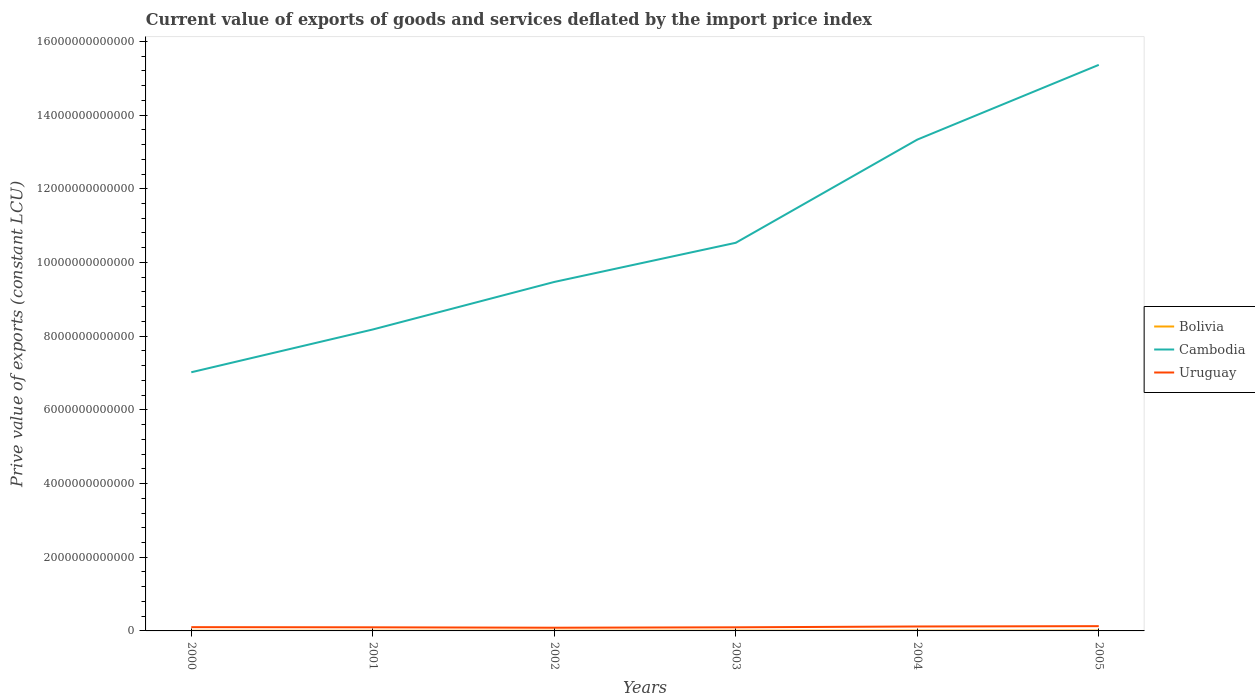How many different coloured lines are there?
Give a very brief answer. 3. Is the number of lines equal to the number of legend labels?
Keep it short and to the point. Yes. Across all years, what is the maximum prive value of exports in Uruguay?
Your answer should be compact. 8.71e+1. In which year was the prive value of exports in Bolivia maximum?
Give a very brief answer. 2000. What is the total prive value of exports in Cambodia in the graph?
Keep it short and to the point. -2.03e+12. What is the difference between the highest and the second highest prive value of exports in Bolivia?
Give a very brief answer. 5.01e+09. What is the difference between two consecutive major ticks on the Y-axis?
Offer a very short reply. 2.00e+12. What is the title of the graph?
Keep it short and to the point. Current value of exports of goods and services deflated by the import price index. Does "Libya" appear as one of the legend labels in the graph?
Give a very brief answer. No. What is the label or title of the Y-axis?
Your response must be concise. Prive value of exports (constant LCU). What is the Prive value of exports (constant LCU) in Bolivia in 2000?
Offer a terse response. 4.27e+09. What is the Prive value of exports (constant LCU) in Cambodia in 2000?
Make the answer very short. 7.02e+12. What is the Prive value of exports (constant LCU) of Uruguay in 2000?
Provide a short and direct response. 1.02e+11. What is the Prive value of exports (constant LCU) in Bolivia in 2001?
Your response must be concise. 4.80e+09. What is the Prive value of exports (constant LCU) of Cambodia in 2001?
Your response must be concise. 8.18e+12. What is the Prive value of exports (constant LCU) in Uruguay in 2001?
Ensure brevity in your answer.  9.80e+1. What is the Prive value of exports (constant LCU) in Bolivia in 2002?
Your answer should be compact. 5.35e+09. What is the Prive value of exports (constant LCU) in Cambodia in 2002?
Keep it short and to the point. 9.47e+12. What is the Prive value of exports (constant LCU) in Uruguay in 2002?
Your response must be concise. 8.71e+1. What is the Prive value of exports (constant LCU) in Bolivia in 2003?
Give a very brief answer. 6.72e+09. What is the Prive value of exports (constant LCU) of Cambodia in 2003?
Ensure brevity in your answer.  1.05e+13. What is the Prive value of exports (constant LCU) in Uruguay in 2003?
Keep it short and to the point. 9.78e+1. What is the Prive value of exports (constant LCU) of Bolivia in 2004?
Give a very brief answer. 8.63e+09. What is the Prive value of exports (constant LCU) of Cambodia in 2004?
Provide a short and direct response. 1.33e+13. What is the Prive value of exports (constant LCU) in Uruguay in 2004?
Your response must be concise. 1.20e+11. What is the Prive value of exports (constant LCU) in Bolivia in 2005?
Your answer should be compact. 9.28e+09. What is the Prive value of exports (constant LCU) in Cambodia in 2005?
Your answer should be very brief. 1.54e+13. What is the Prive value of exports (constant LCU) in Uruguay in 2005?
Ensure brevity in your answer.  1.29e+11. Across all years, what is the maximum Prive value of exports (constant LCU) of Bolivia?
Give a very brief answer. 9.28e+09. Across all years, what is the maximum Prive value of exports (constant LCU) of Cambodia?
Provide a succinct answer. 1.54e+13. Across all years, what is the maximum Prive value of exports (constant LCU) in Uruguay?
Your answer should be very brief. 1.29e+11. Across all years, what is the minimum Prive value of exports (constant LCU) in Bolivia?
Make the answer very short. 4.27e+09. Across all years, what is the minimum Prive value of exports (constant LCU) in Cambodia?
Your answer should be compact. 7.02e+12. Across all years, what is the minimum Prive value of exports (constant LCU) of Uruguay?
Your answer should be compact. 8.71e+1. What is the total Prive value of exports (constant LCU) of Bolivia in the graph?
Make the answer very short. 3.91e+1. What is the total Prive value of exports (constant LCU) in Cambodia in the graph?
Your answer should be very brief. 6.39e+13. What is the total Prive value of exports (constant LCU) in Uruguay in the graph?
Give a very brief answer. 6.34e+11. What is the difference between the Prive value of exports (constant LCU) of Bolivia in 2000 and that in 2001?
Give a very brief answer. -5.24e+08. What is the difference between the Prive value of exports (constant LCU) in Cambodia in 2000 and that in 2001?
Your answer should be very brief. -1.16e+12. What is the difference between the Prive value of exports (constant LCU) of Uruguay in 2000 and that in 2001?
Offer a terse response. 4.12e+09. What is the difference between the Prive value of exports (constant LCU) in Bolivia in 2000 and that in 2002?
Keep it short and to the point. -1.08e+09. What is the difference between the Prive value of exports (constant LCU) in Cambodia in 2000 and that in 2002?
Your answer should be very brief. -2.45e+12. What is the difference between the Prive value of exports (constant LCU) of Uruguay in 2000 and that in 2002?
Ensure brevity in your answer.  1.50e+1. What is the difference between the Prive value of exports (constant LCU) of Bolivia in 2000 and that in 2003?
Offer a very short reply. -2.45e+09. What is the difference between the Prive value of exports (constant LCU) in Cambodia in 2000 and that in 2003?
Your response must be concise. -3.51e+12. What is the difference between the Prive value of exports (constant LCU) of Uruguay in 2000 and that in 2003?
Offer a very short reply. 4.28e+09. What is the difference between the Prive value of exports (constant LCU) in Bolivia in 2000 and that in 2004?
Keep it short and to the point. -4.36e+09. What is the difference between the Prive value of exports (constant LCU) of Cambodia in 2000 and that in 2004?
Offer a very short reply. -6.31e+12. What is the difference between the Prive value of exports (constant LCU) in Uruguay in 2000 and that in 2004?
Keep it short and to the point. -1.82e+1. What is the difference between the Prive value of exports (constant LCU) of Bolivia in 2000 and that in 2005?
Ensure brevity in your answer.  -5.01e+09. What is the difference between the Prive value of exports (constant LCU) of Cambodia in 2000 and that in 2005?
Your answer should be very brief. -8.34e+12. What is the difference between the Prive value of exports (constant LCU) in Uruguay in 2000 and that in 2005?
Offer a very short reply. -2.71e+1. What is the difference between the Prive value of exports (constant LCU) in Bolivia in 2001 and that in 2002?
Keep it short and to the point. -5.58e+08. What is the difference between the Prive value of exports (constant LCU) in Cambodia in 2001 and that in 2002?
Give a very brief answer. -1.29e+12. What is the difference between the Prive value of exports (constant LCU) of Uruguay in 2001 and that in 2002?
Offer a very short reply. 1.09e+1. What is the difference between the Prive value of exports (constant LCU) of Bolivia in 2001 and that in 2003?
Give a very brief answer. -1.92e+09. What is the difference between the Prive value of exports (constant LCU) of Cambodia in 2001 and that in 2003?
Offer a very short reply. -2.35e+12. What is the difference between the Prive value of exports (constant LCU) of Uruguay in 2001 and that in 2003?
Give a very brief answer. 1.57e+08. What is the difference between the Prive value of exports (constant LCU) in Bolivia in 2001 and that in 2004?
Give a very brief answer. -3.84e+09. What is the difference between the Prive value of exports (constant LCU) in Cambodia in 2001 and that in 2004?
Make the answer very short. -5.15e+12. What is the difference between the Prive value of exports (constant LCU) of Uruguay in 2001 and that in 2004?
Offer a very short reply. -2.23e+1. What is the difference between the Prive value of exports (constant LCU) of Bolivia in 2001 and that in 2005?
Provide a short and direct response. -4.49e+09. What is the difference between the Prive value of exports (constant LCU) in Cambodia in 2001 and that in 2005?
Your response must be concise. -7.18e+12. What is the difference between the Prive value of exports (constant LCU) of Uruguay in 2001 and that in 2005?
Your answer should be compact. -3.13e+1. What is the difference between the Prive value of exports (constant LCU) of Bolivia in 2002 and that in 2003?
Give a very brief answer. -1.37e+09. What is the difference between the Prive value of exports (constant LCU) in Cambodia in 2002 and that in 2003?
Offer a very short reply. -1.06e+12. What is the difference between the Prive value of exports (constant LCU) of Uruguay in 2002 and that in 2003?
Keep it short and to the point. -1.07e+1. What is the difference between the Prive value of exports (constant LCU) in Bolivia in 2002 and that in 2004?
Ensure brevity in your answer.  -3.28e+09. What is the difference between the Prive value of exports (constant LCU) in Cambodia in 2002 and that in 2004?
Make the answer very short. -3.86e+12. What is the difference between the Prive value of exports (constant LCU) in Uruguay in 2002 and that in 2004?
Keep it short and to the point. -3.31e+1. What is the difference between the Prive value of exports (constant LCU) of Bolivia in 2002 and that in 2005?
Offer a terse response. -3.93e+09. What is the difference between the Prive value of exports (constant LCU) in Cambodia in 2002 and that in 2005?
Your response must be concise. -5.89e+12. What is the difference between the Prive value of exports (constant LCU) of Uruguay in 2002 and that in 2005?
Offer a terse response. -4.21e+1. What is the difference between the Prive value of exports (constant LCU) of Bolivia in 2003 and that in 2004?
Make the answer very short. -1.91e+09. What is the difference between the Prive value of exports (constant LCU) of Cambodia in 2003 and that in 2004?
Your answer should be compact. -2.80e+12. What is the difference between the Prive value of exports (constant LCU) in Uruguay in 2003 and that in 2004?
Provide a short and direct response. -2.24e+1. What is the difference between the Prive value of exports (constant LCU) of Bolivia in 2003 and that in 2005?
Provide a short and direct response. -2.56e+09. What is the difference between the Prive value of exports (constant LCU) in Cambodia in 2003 and that in 2005?
Offer a terse response. -4.83e+12. What is the difference between the Prive value of exports (constant LCU) of Uruguay in 2003 and that in 2005?
Give a very brief answer. -3.14e+1. What is the difference between the Prive value of exports (constant LCU) of Bolivia in 2004 and that in 2005?
Keep it short and to the point. -6.47e+08. What is the difference between the Prive value of exports (constant LCU) in Cambodia in 2004 and that in 2005?
Your answer should be compact. -2.03e+12. What is the difference between the Prive value of exports (constant LCU) in Uruguay in 2004 and that in 2005?
Ensure brevity in your answer.  -8.98e+09. What is the difference between the Prive value of exports (constant LCU) in Bolivia in 2000 and the Prive value of exports (constant LCU) in Cambodia in 2001?
Ensure brevity in your answer.  -8.18e+12. What is the difference between the Prive value of exports (constant LCU) in Bolivia in 2000 and the Prive value of exports (constant LCU) in Uruguay in 2001?
Give a very brief answer. -9.37e+1. What is the difference between the Prive value of exports (constant LCU) in Cambodia in 2000 and the Prive value of exports (constant LCU) in Uruguay in 2001?
Make the answer very short. 6.92e+12. What is the difference between the Prive value of exports (constant LCU) of Bolivia in 2000 and the Prive value of exports (constant LCU) of Cambodia in 2002?
Provide a short and direct response. -9.47e+12. What is the difference between the Prive value of exports (constant LCU) in Bolivia in 2000 and the Prive value of exports (constant LCU) in Uruguay in 2002?
Your answer should be compact. -8.28e+1. What is the difference between the Prive value of exports (constant LCU) of Cambodia in 2000 and the Prive value of exports (constant LCU) of Uruguay in 2002?
Your answer should be very brief. 6.93e+12. What is the difference between the Prive value of exports (constant LCU) in Bolivia in 2000 and the Prive value of exports (constant LCU) in Cambodia in 2003?
Keep it short and to the point. -1.05e+13. What is the difference between the Prive value of exports (constant LCU) of Bolivia in 2000 and the Prive value of exports (constant LCU) of Uruguay in 2003?
Ensure brevity in your answer.  -9.35e+1. What is the difference between the Prive value of exports (constant LCU) in Cambodia in 2000 and the Prive value of exports (constant LCU) in Uruguay in 2003?
Ensure brevity in your answer.  6.92e+12. What is the difference between the Prive value of exports (constant LCU) in Bolivia in 2000 and the Prive value of exports (constant LCU) in Cambodia in 2004?
Offer a very short reply. -1.33e+13. What is the difference between the Prive value of exports (constant LCU) of Bolivia in 2000 and the Prive value of exports (constant LCU) of Uruguay in 2004?
Your response must be concise. -1.16e+11. What is the difference between the Prive value of exports (constant LCU) in Cambodia in 2000 and the Prive value of exports (constant LCU) in Uruguay in 2004?
Your answer should be compact. 6.90e+12. What is the difference between the Prive value of exports (constant LCU) in Bolivia in 2000 and the Prive value of exports (constant LCU) in Cambodia in 2005?
Offer a terse response. -1.54e+13. What is the difference between the Prive value of exports (constant LCU) of Bolivia in 2000 and the Prive value of exports (constant LCU) of Uruguay in 2005?
Offer a terse response. -1.25e+11. What is the difference between the Prive value of exports (constant LCU) in Cambodia in 2000 and the Prive value of exports (constant LCU) in Uruguay in 2005?
Provide a short and direct response. 6.89e+12. What is the difference between the Prive value of exports (constant LCU) of Bolivia in 2001 and the Prive value of exports (constant LCU) of Cambodia in 2002?
Ensure brevity in your answer.  -9.47e+12. What is the difference between the Prive value of exports (constant LCU) in Bolivia in 2001 and the Prive value of exports (constant LCU) in Uruguay in 2002?
Offer a very short reply. -8.23e+1. What is the difference between the Prive value of exports (constant LCU) in Cambodia in 2001 and the Prive value of exports (constant LCU) in Uruguay in 2002?
Provide a short and direct response. 8.09e+12. What is the difference between the Prive value of exports (constant LCU) in Bolivia in 2001 and the Prive value of exports (constant LCU) in Cambodia in 2003?
Your answer should be very brief. -1.05e+13. What is the difference between the Prive value of exports (constant LCU) of Bolivia in 2001 and the Prive value of exports (constant LCU) of Uruguay in 2003?
Your response must be concise. -9.30e+1. What is the difference between the Prive value of exports (constant LCU) of Cambodia in 2001 and the Prive value of exports (constant LCU) of Uruguay in 2003?
Your answer should be compact. 8.08e+12. What is the difference between the Prive value of exports (constant LCU) of Bolivia in 2001 and the Prive value of exports (constant LCU) of Cambodia in 2004?
Give a very brief answer. -1.33e+13. What is the difference between the Prive value of exports (constant LCU) of Bolivia in 2001 and the Prive value of exports (constant LCU) of Uruguay in 2004?
Your response must be concise. -1.15e+11. What is the difference between the Prive value of exports (constant LCU) of Cambodia in 2001 and the Prive value of exports (constant LCU) of Uruguay in 2004?
Provide a short and direct response. 8.06e+12. What is the difference between the Prive value of exports (constant LCU) in Bolivia in 2001 and the Prive value of exports (constant LCU) in Cambodia in 2005?
Ensure brevity in your answer.  -1.54e+13. What is the difference between the Prive value of exports (constant LCU) in Bolivia in 2001 and the Prive value of exports (constant LCU) in Uruguay in 2005?
Provide a short and direct response. -1.24e+11. What is the difference between the Prive value of exports (constant LCU) in Cambodia in 2001 and the Prive value of exports (constant LCU) in Uruguay in 2005?
Your response must be concise. 8.05e+12. What is the difference between the Prive value of exports (constant LCU) of Bolivia in 2002 and the Prive value of exports (constant LCU) of Cambodia in 2003?
Offer a terse response. -1.05e+13. What is the difference between the Prive value of exports (constant LCU) in Bolivia in 2002 and the Prive value of exports (constant LCU) in Uruguay in 2003?
Keep it short and to the point. -9.24e+1. What is the difference between the Prive value of exports (constant LCU) of Cambodia in 2002 and the Prive value of exports (constant LCU) of Uruguay in 2003?
Provide a succinct answer. 9.37e+12. What is the difference between the Prive value of exports (constant LCU) of Bolivia in 2002 and the Prive value of exports (constant LCU) of Cambodia in 2004?
Offer a terse response. -1.33e+13. What is the difference between the Prive value of exports (constant LCU) of Bolivia in 2002 and the Prive value of exports (constant LCU) of Uruguay in 2004?
Give a very brief answer. -1.15e+11. What is the difference between the Prive value of exports (constant LCU) of Cambodia in 2002 and the Prive value of exports (constant LCU) of Uruguay in 2004?
Your answer should be compact. 9.35e+12. What is the difference between the Prive value of exports (constant LCU) of Bolivia in 2002 and the Prive value of exports (constant LCU) of Cambodia in 2005?
Offer a very short reply. -1.54e+13. What is the difference between the Prive value of exports (constant LCU) of Bolivia in 2002 and the Prive value of exports (constant LCU) of Uruguay in 2005?
Offer a very short reply. -1.24e+11. What is the difference between the Prive value of exports (constant LCU) in Cambodia in 2002 and the Prive value of exports (constant LCU) in Uruguay in 2005?
Offer a terse response. 9.34e+12. What is the difference between the Prive value of exports (constant LCU) of Bolivia in 2003 and the Prive value of exports (constant LCU) of Cambodia in 2004?
Your answer should be very brief. -1.33e+13. What is the difference between the Prive value of exports (constant LCU) in Bolivia in 2003 and the Prive value of exports (constant LCU) in Uruguay in 2004?
Offer a very short reply. -1.14e+11. What is the difference between the Prive value of exports (constant LCU) in Cambodia in 2003 and the Prive value of exports (constant LCU) in Uruguay in 2004?
Provide a succinct answer. 1.04e+13. What is the difference between the Prive value of exports (constant LCU) in Bolivia in 2003 and the Prive value of exports (constant LCU) in Cambodia in 2005?
Offer a very short reply. -1.54e+13. What is the difference between the Prive value of exports (constant LCU) of Bolivia in 2003 and the Prive value of exports (constant LCU) of Uruguay in 2005?
Provide a short and direct response. -1.23e+11. What is the difference between the Prive value of exports (constant LCU) of Cambodia in 2003 and the Prive value of exports (constant LCU) of Uruguay in 2005?
Provide a succinct answer. 1.04e+13. What is the difference between the Prive value of exports (constant LCU) in Bolivia in 2004 and the Prive value of exports (constant LCU) in Cambodia in 2005?
Ensure brevity in your answer.  -1.54e+13. What is the difference between the Prive value of exports (constant LCU) in Bolivia in 2004 and the Prive value of exports (constant LCU) in Uruguay in 2005?
Keep it short and to the point. -1.21e+11. What is the difference between the Prive value of exports (constant LCU) of Cambodia in 2004 and the Prive value of exports (constant LCU) of Uruguay in 2005?
Provide a short and direct response. 1.32e+13. What is the average Prive value of exports (constant LCU) in Bolivia per year?
Ensure brevity in your answer.  6.51e+09. What is the average Prive value of exports (constant LCU) of Cambodia per year?
Keep it short and to the point. 1.06e+13. What is the average Prive value of exports (constant LCU) in Uruguay per year?
Offer a terse response. 1.06e+11. In the year 2000, what is the difference between the Prive value of exports (constant LCU) of Bolivia and Prive value of exports (constant LCU) of Cambodia?
Your response must be concise. -7.02e+12. In the year 2000, what is the difference between the Prive value of exports (constant LCU) of Bolivia and Prive value of exports (constant LCU) of Uruguay?
Offer a terse response. -9.78e+1. In the year 2000, what is the difference between the Prive value of exports (constant LCU) in Cambodia and Prive value of exports (constant LCU) in Uruguay?
Provide a short and direct response. 6.92e+12. In the year 2001, what is the difference between the Prive value of exports (constant LCU) of Bolivia and Prive value of exports (constant LCU) of Cambodia?
Your answer should be compact. -8.18e+12. In the year 2001, what is the difference between the Prive value of exports (constant LCU) in Bolivia and Prive value of exports (constant LCU) in Uruguay?
Provide a short and direct response. -9.32e+1. In the year 2001, what is the difference between the Prive value of exports (constant LCU) of Cambodia and Prive value of exports (constant LCU) of Uruguay?
Provide a short and direct response. 8.08e+12. In the year 2002, what is the difference between the Prive value of exports (constant LCU) in Bolivia and Prive value of exports (constant LCU) in Cambodia?
Keep it short and to the point. -9.47e+12. In the year 2002, what is the difference between the Prive value of exports (constant LCU) of Bolivia and Prive value of exports (constant LCU) of Uruguay?
Your answer should be very brief. -8.17e+1. In the year 2002, what is the difference between the Prive value of exports (constant LCU) of Cambodia and Prive value of exports (constant LCU) of Uruguay?
Your response must be concise. 9.38e+12. In the year 2003, what is the difference between the Prive value of exports (constant LCU) of Bolivia and Prive value of exports (constant LCU) of Cambodia?
Provide a succinct answer. -1.05e+13. In the year 2003, what is the difference between the Prive value of exports (constant LCU) of Bolivia and Prive value of exports (constant LCU) of Uruguay?
Provide a short and direct response. -9.11e+1. In the year 2003, what is the difference between the Prive value of exports (constant LCU) of Cambodia and Prive value of exports (constant LCU) of Uruguay?
Offer a terse response. 1.04e+13. In the year 2004, what is the difference between the Prive value of exports (constant LCU) of Bolivia and Prive value of exports (constant LCU) of Cambodia?
Keep it short and to the point. -1.33e+13. In the year 2004, what is the difference between the Prive value of exports (constant LCU) in Bolivia and Prive value of exports (constant LCU) in Uruguay?
Give a very brief answer. -1.12e+11. In the year 2004, what is the difference between the Prive value of exports (constant LCU) of Cambodia and Prive value of exports (constant LCU) of Uruguay?
Give a very brief answer. 1.32e+13. In the year 2005, what is the difference between the Prive value of exports (constant LCU) in Bolivia and Prive value of exports (constant LCU) in Cambodia?
Provide a succinct answer. -1.54e+13. In the year 2005, what is the difference between the Prive value of exports (constant LCU) of Bolivia and Prive value of exports (constant LCU) of Uruguay?
Your response must be concise. -1.20e+11. In the year 2005, what is the difference between the Prive value of exports (constant LCU) of Cambodia and Prive value of exports (constant LCU) of Uruguay?
Make the answer very short. 1.52e+13. What is the ratio of the Prive value of exports (constant LCU) of Bolivia in 2000 to that in 2001?
Give a very brief answer. 0.89. What is the ratio of the Prive value of exports (constant LCU) in Cambodia in 2000 to that in 2001?
Keep it short and to the point. 0.86. What is the ratio of the Prive value of exports (constant LCU) of Uruguay in 2000 to that in 2001?
Offer a terse response. 1.04. What is the ratio of the Prive value of exports (constant LCU) in Bolivia in 2000 to that in 2002?
Your response must be concise. 0.8. What is the ratio of the Prive value of exports (constant LCU) of Cambodia in 2000 to that in 2002?
Make the answer very short. 0.74. What is the ratio of the Prive value of exports (constant LCU) in Uruguay in 2000 to that in 2002?
Ensure brevity in your answer.  1.17. What is the ratio of the Prive value of exports (constant LCU) of Bolivia in 2000 to that in 2003?
Your answer should be very brief. 0.64. What is the ratio of the Prive value of exports (constant LCU) of Cambodia in 2000 to that in 2003?
Your response must be concise. 0.67. What is the ratio of the Prive value of exports (constant LCU) of Uruguay in 2000 to that in 2003?
Provide a short and direct response. 1.04. What is the ratio of the Prive value of exports (constant LCU) in Bolivia in 2000 to that in 2004?
Your answer should be compact. 0.49. What is the ratio of the Prive value of exports (constant LCU) of Cambodia in 2000 to that in 2004?
Your response must be concise. 0.53. What is the ratio of the Prive value of exports (constant LCU) in Uruguay in 2000 to that in 2004?
Ensure brevity in your answer.  0.85. What is the ratio of the Prive value of exports (constant LCU) of Bolivia in 2000 to that in 2005?
Your answer should be compact. 0.46. What is the ratio of the Prive value of exports (constant LCU) of Cambodia in 2000 to that in 2005?
Keep it short and to the point. 0.46. What is the ratio of the Prive value of exports (constant LCU) in Uruguay in 2000 to that in 2005?
Offer a very short reply. 0.79. What is the ratio of the Prive value of exports (constant LCU) in Bolivia in 2001 to that in 2002?
Your response must be concise. 0.9. What is the ratio of the Prive value of exports (constant LCU) of Cambodia in 2001 to that in 2002?
Offer a terse response. 0.86. What is the ratio of the Prive value of exports (constant LCU) of Uruguay in 2001 to that in 2002?
Your answer should be compact. 1.12. What is the ratio of the Prive value of exports (constant LCU) in Bolivia in 2001 to that in 2003?
Offer a terse response. 0.71. What is the ratio of the Prive value of exports (constant LCU) of Cambodia in 2001 to that in 2003?
Provide a succinct answer. 0.78. What is the ratio of the Prive value of exports (constant LCU) in Uruguay in 2001 to that in 2003?
Provide a short and direct response. 1. What is the ratio of the Prive value of exports (constant LCU) of Bolivia in 2001 to that in 2004?
Offer a terse response. 0.56. What is the ratio of the Prive value of exports (constant LCU) of Cambodia in 2001 to that in 2004?
Offer a very short reply. 0.61. What is the ratio of the Prive value of exports (constant LCU) of Uruguay in 2001 to that in 2004?
Provide a succinct answer. 0.81. What is the ratio of the Prive value of exports (constant LCU) in Bolivia in 2001 to that in 2005?
Make the answer very short. 0.52. What is the ratio of the Prive value of exports (constant LCU) of Cambodia in 2001 to that in 2005?
Keep it short and to the point. 0.53. What is the ratio of the Prive value of exports (constant LCU) in Uruguay in 2001 to that in 2005?
Make the answer very short. 0.76. What is the ratio of the Prive value of exports (constant LCU) of Bolivia in 2002 to that in 2003?
Offer a very short reply. 0.8. What is the ratio of the Prive value of exports (constant LCU) in Cambodia in 2002 to that in 2003?
Offer a terse response. 0.9. What is the ratio of the Prive value of exports (constant LCU) in Uruguay in 2002 to that in 2003?
Your answer should be very brief. 0.89. What is the ratio of the Prive value of exports (constant LCU) of Bolivia in 2002 to that in 2004?
Give a very brief answer. 0.62. What is the ratio of the Prive value of exports (constant LCU) in Cambodia in 2002 to that in 2004?
Your response must be concise. 0.71. What is the ratio of the Prive value of exports (constant LCU) of Uruguay in 2002 to that in 2004?
Provide a succinct answer. 0.72. What is the ratio of the Prive value of exports (constant LCU) of Bolivia in 2002 to that in 2005?
Your answer should be compact. 0.58. What is the ratio of the Prive value of exports (constant LCU) in Cambodia in 2002 to that in 2005?
Provide a succinct answer. 0.62. What is the ratio of the Prive value of exports (constant LCU) of Uruguay in 2002 to that in 2005?
Offer a very short reply. 0.67. What is the ratio of the Prive value of exports (constant LCU) of Bolivia in 2003 to that in 2004?
Provide a short and direct response. 0.78. What is the ratio of the Prive value of exports (constant LCU) of Cambodia in 2003 to that in 2004?
Offer a very short reply. 0.79. What is the ratio of the Prive value of exports (constant LCU) in Uruguay in 2003 to that in 2004?
Your response must be concise. 0.81. What is the ratio of the Prive value of exports (constant LCU) of Bolivia in 2003 to that in 2005?
Your answer should be very brief. 0.72. What is the ratio of the Prive value of exports (constant LCU) in Cambodia in 2003 to that in 2005?
Your response must be concise. 0.69. What is the ratio of the Prive value of exports (constant LCU) in Uruguay in 2003 to that in 2005?
Keep it short and to the point. 0.76. What is the ratio of the Prive value of exports (constant LCU) of Bolivia in 2004 to that in 2005?
Your answer should be very brief. 0.93. What is the ratio of the Prive value of exports (constant LCU) in Cambodia in 2004 to that in 2005?
Your answer should be compact. 0.87. What is the ratio of the Prive value of exports (constant LCU) in Uruguay in 2004 to that in 2005?
Offer a terse response. 0.93. What is the difference between the highest and the second highest Prive value of exports (constant LCU) in Bolivia?
Provide a short and direct response. 6.47e+08. What is the difference between the highest and the second highest Prive value of exports (constant LCU) in Cambodia?
Offer a terse response. 2.03e+12. What is the difference between the highest and the second highest Prive value of exports (constant LCU) of Uruguay?
Your response must be concise. 8.98e+09. What is the difference between the highest and the lowest Prive value of exports (constant LCU) in Bolivia?
Provide a short and direct response. 5.01e+09. What is the difference between the highest and the lowest Prive value of exports (constant LCU) of Cambodia?
Provide a short and direct response. 8.34e+12. What is the difference between the highest and the lowest Prive value of exports (constant LCU) of Uruguay?
Keep it short and to the point. 4.21e+1. 